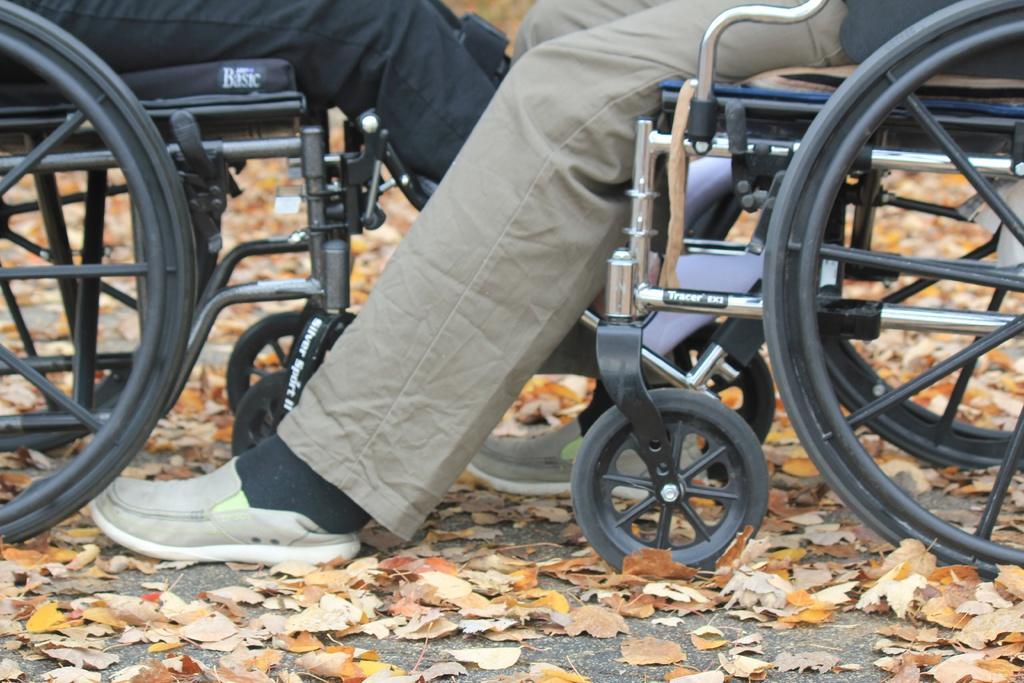Describe this image in one or two sentences. In this image we can see few people sitting on the wheelchairs. There are many leaves on the ground. There are two wheelchairs in the image. 